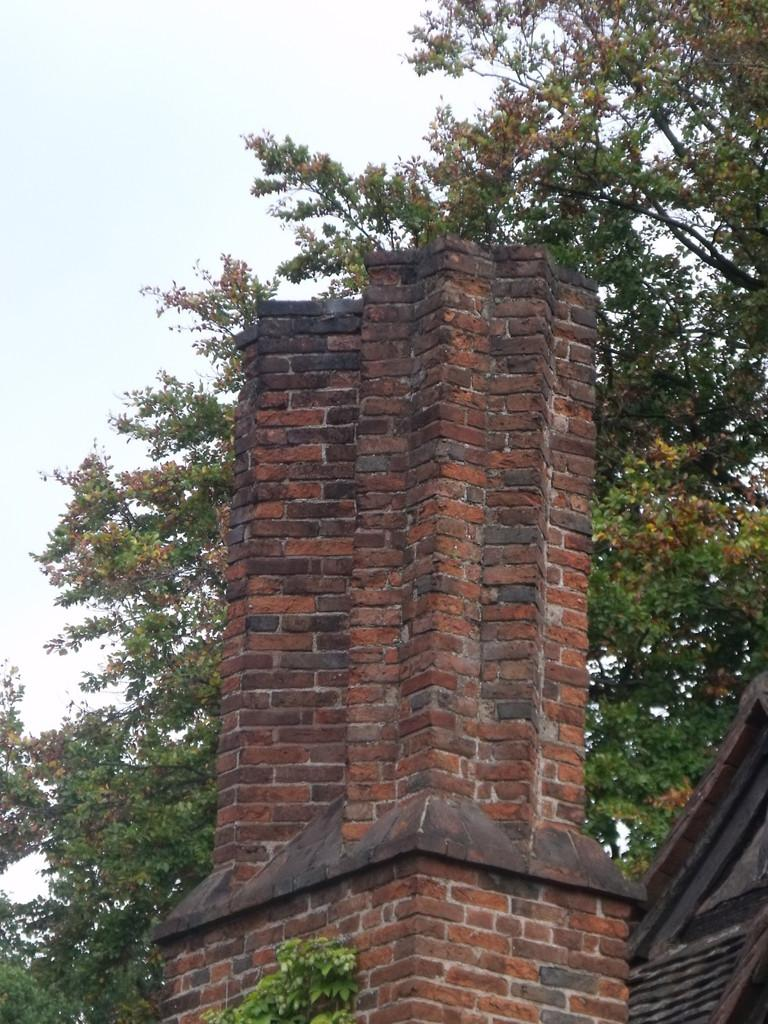What can be seen in the background of the image? There is a sky in the image. What is present in the sky? There are clouds in the image. What type of vegetation can be seen in the image? There are trees in the image. What type of structure is visible in the image? There is a building in the image. What type of bird can be seen singing during the dinner in the image? There is no dinner or bird present in the image. What causes the wren to burst in the image? There is no wren or bursting event present in the image. 